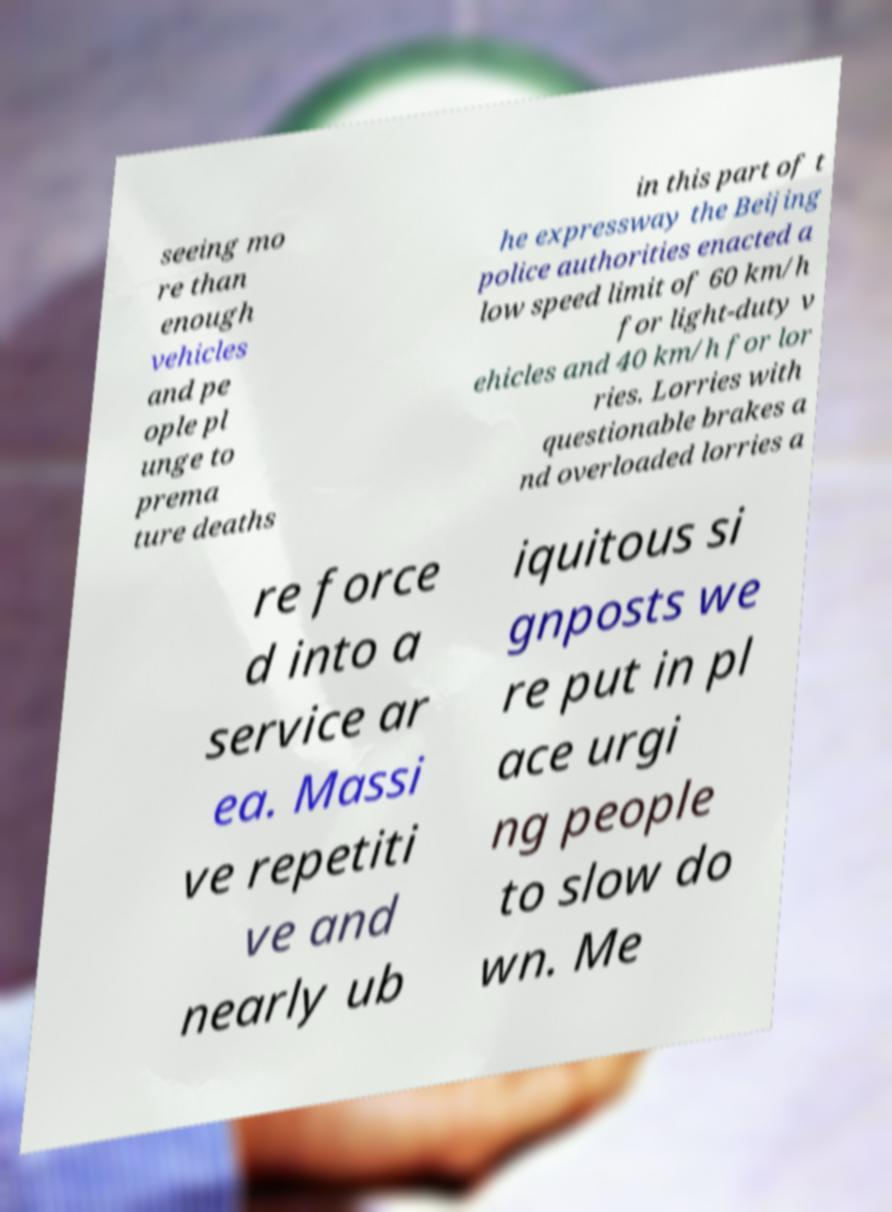I need the written content from this picture converted into text. Can you do that? seeing mo re than enough vehicles and pe ople pl unge to prema ture deaths in this part of t he expressway the Beijing police authorities enacted a low speed limit of 60 km/h for light-duty v ehicles and 40 km/h for lor ries. Lorries with questionable brakes a nd overloaded lorries a re force d into a service ar ea. Massi ve repetiti ve and nearly ub iquitous si gnposts we re put in pl ace urgi ng people to slow do wn. Me 